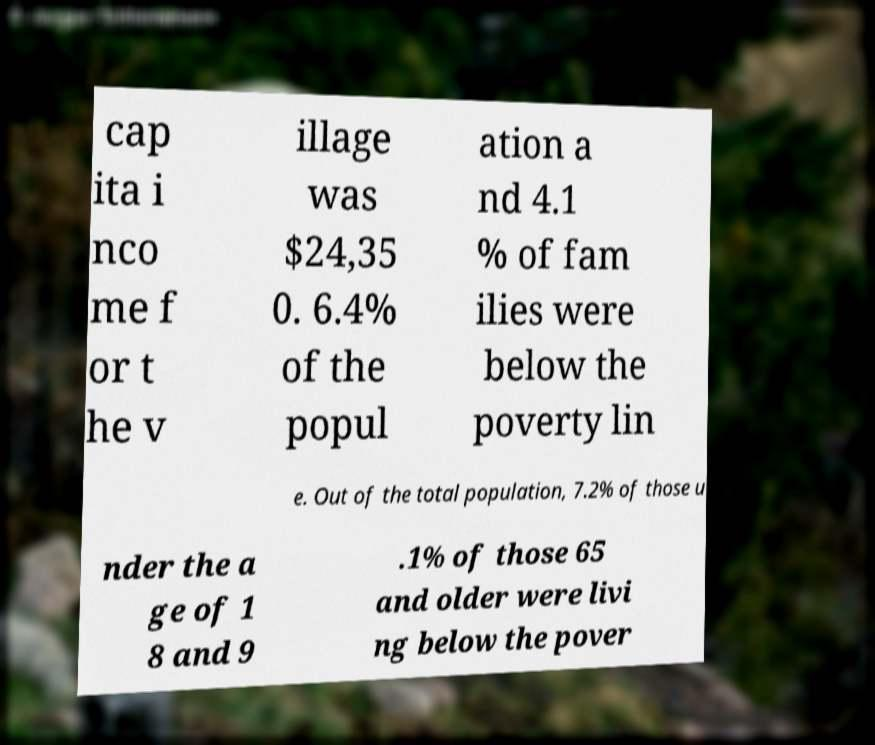Can you read and provide the text displayed in the image?This photo seems to have some interesting text. Can you extract and type it out for me? cap ita i nco me f or t he v illage was $24,35 0. 6.4% of the popul ation a nd 4.1 % of fam ilies were below the poverty lin e. Out of the total population, 7.2% of those u nder the a ge of 1 8 and 9 .1% of those 65 and older were livi ng below the pover 